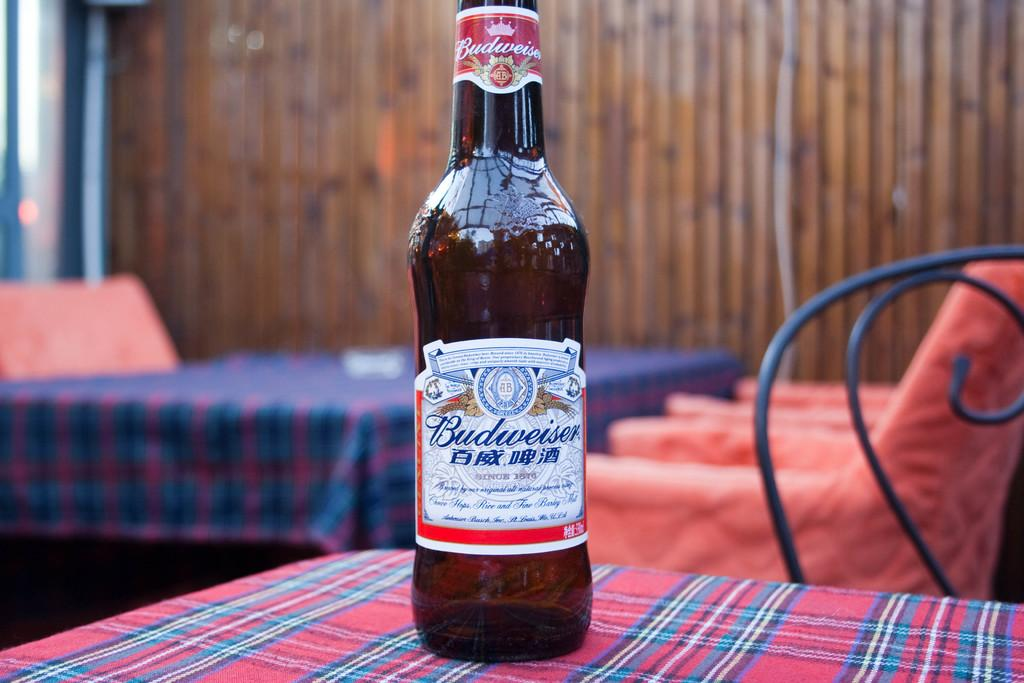What is the name of the bottle in the image? The bottle is named "Budweiser" in the image. Where is the bottle located? The bottle is on a table in the image. What else can be seen on the table in the image? The provided facts do not mention any other items on the table. What can be seen in the background of the image? There is another table visible in the background, and there are chairs present in the background. What type of skirt is draped over the chair in the image? There is no skirt present in the image; the chairs in the background are empty. 